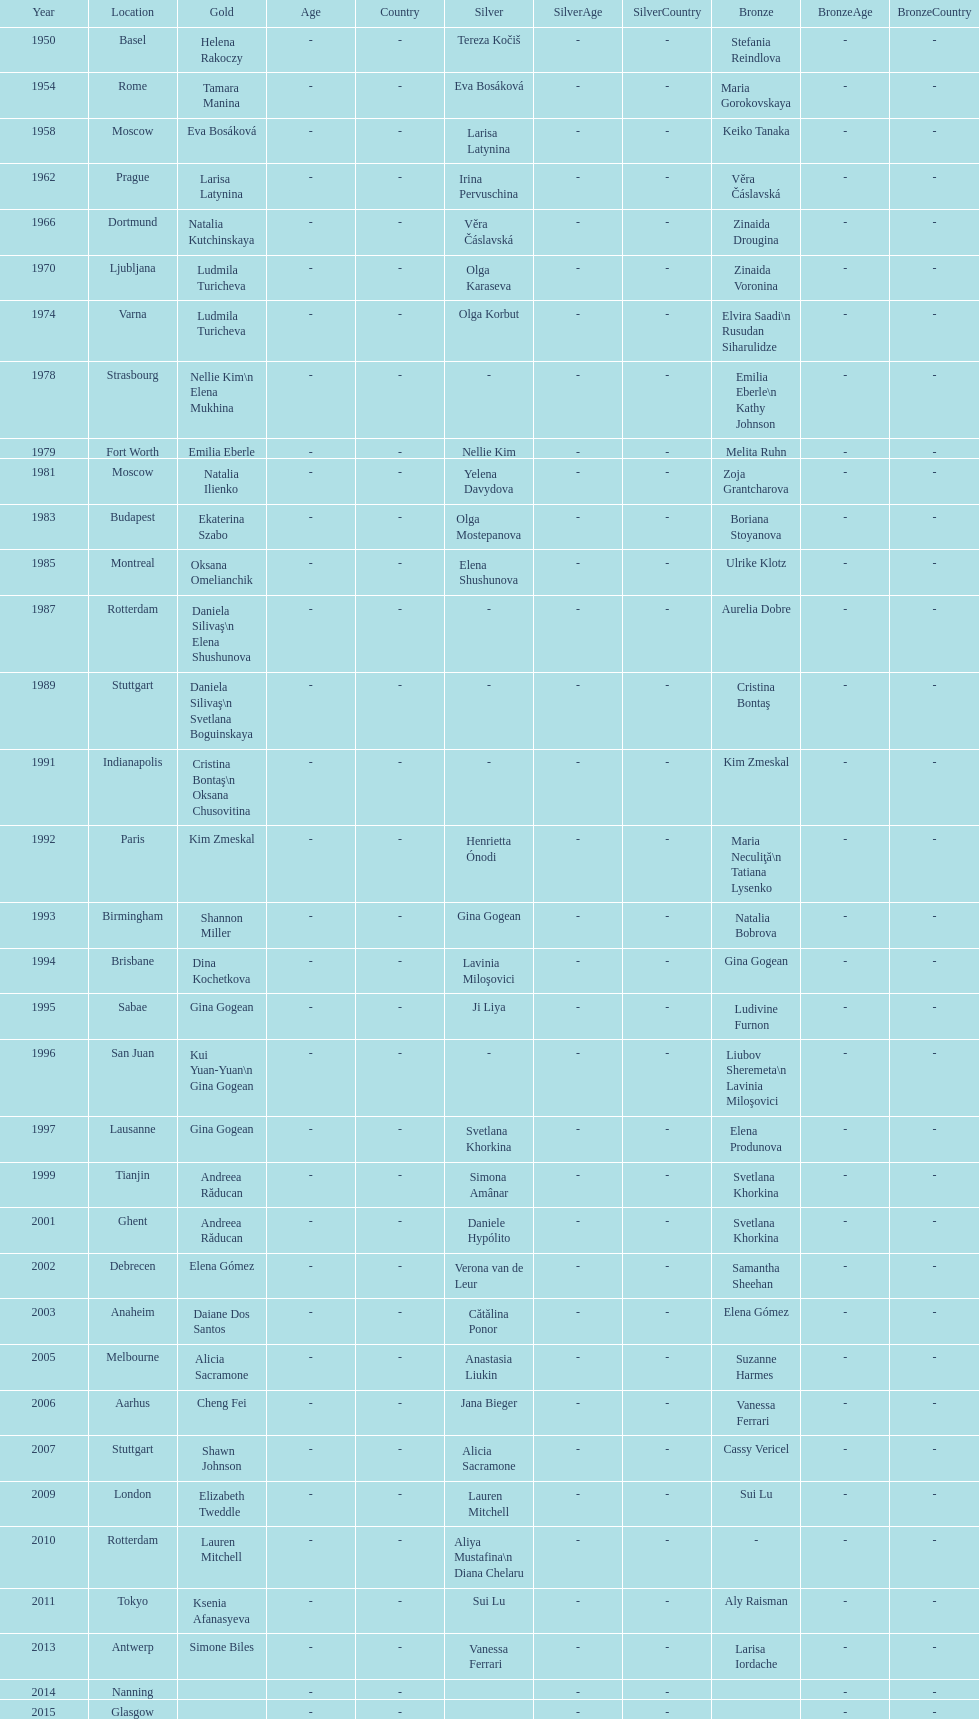How many consecutive floor exercise gold medals did romanian star andreea raducan win at the world championships? 2. 